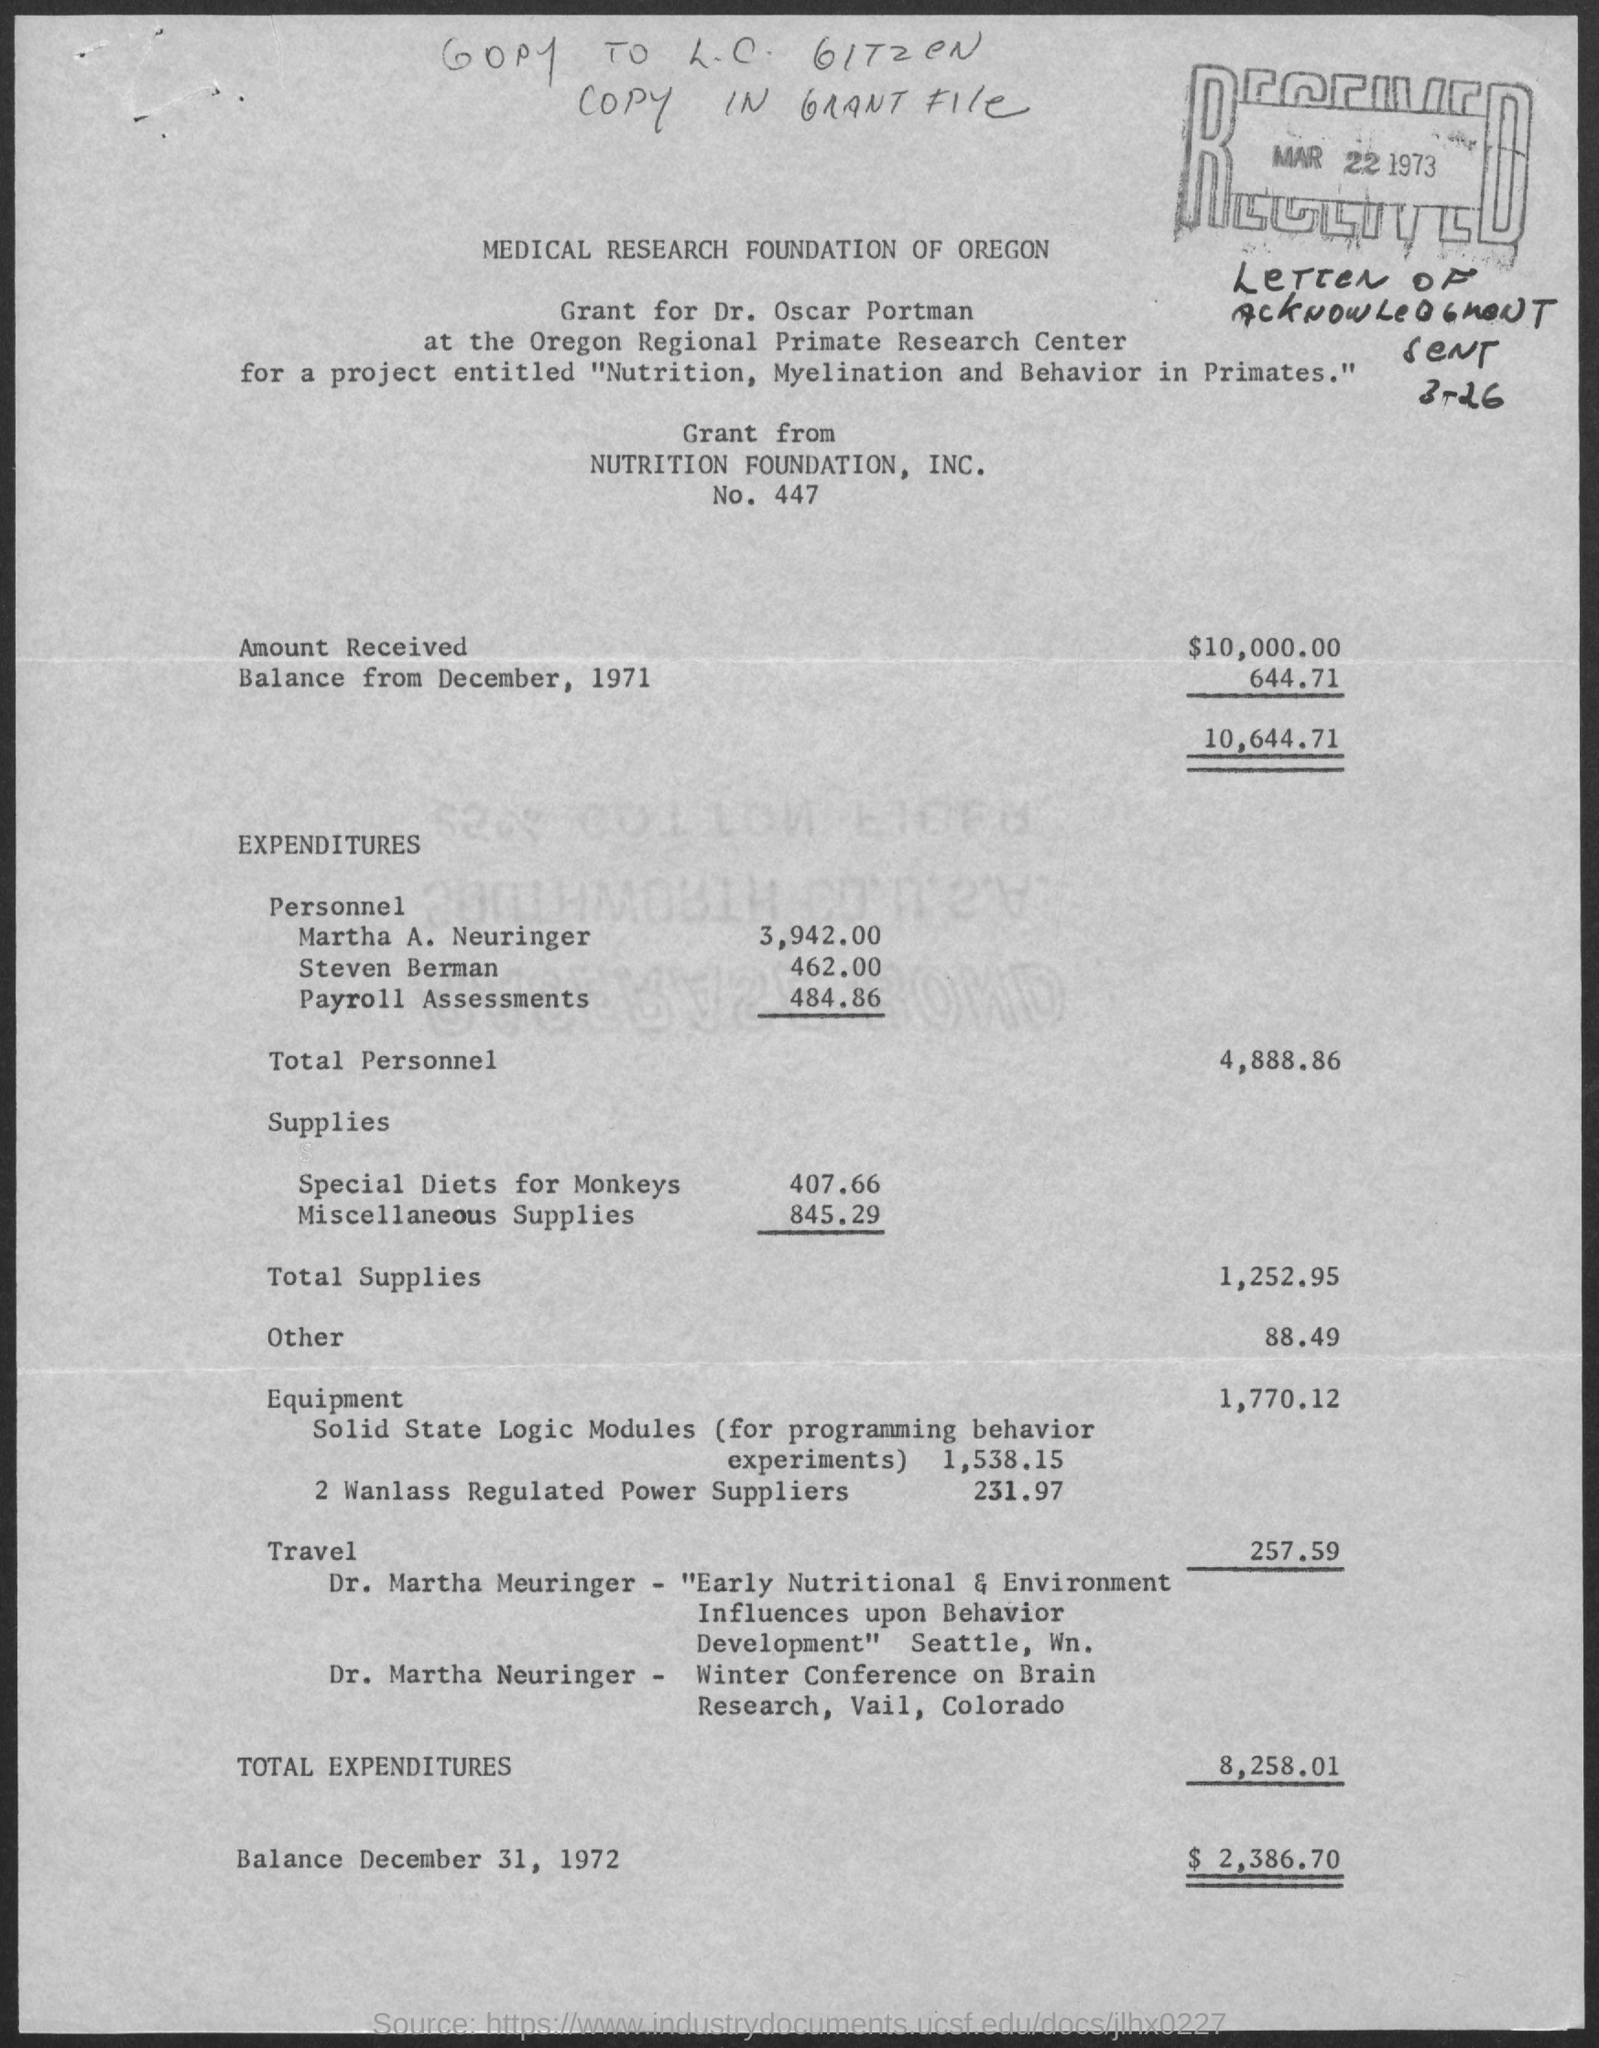To whom is the grant given ?
Your answer should be compact. Dr. Oscar Portman. What is the title of the project for which the grant is given ?
Your answer should be very brief. Nutrition, Myelination and Behavior in Primates. What is the grant amount received ?
Keep it short and to the point. 10000. What is the total personnel expenditure done ?
Give a very brief answer. 4,888.86. What is the total supplies expense?
Give a very brief answer. 1,252.95. What is the travel expenditure ?
Give a very brief answer. 257.59. How much is the total expenditures?
Your response must be concise. 8,258.01. What is the balance amount as of December 31, 1972?
Provide a short and direct response. $ 2,386.70. 